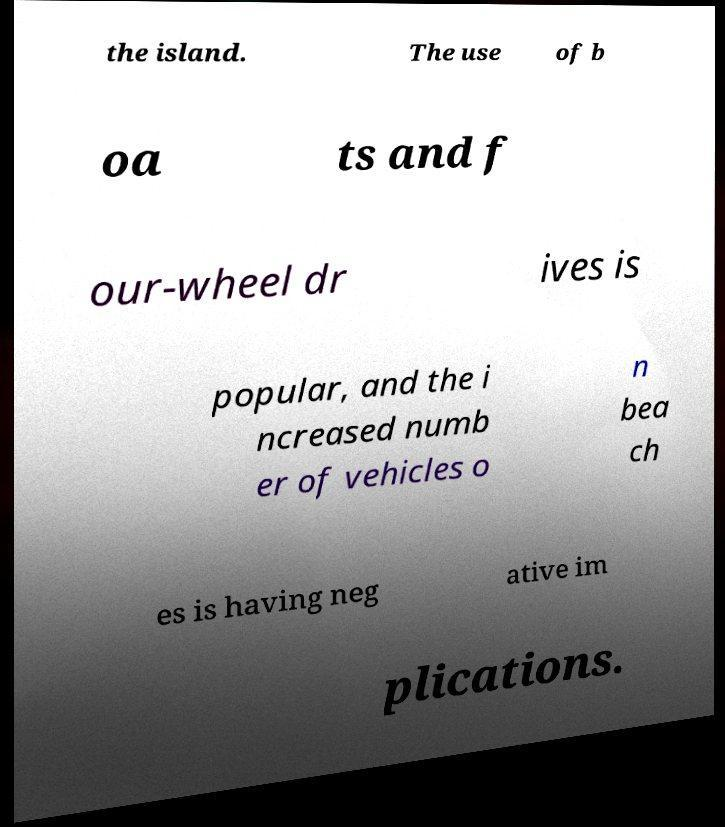I need the written content from this picture converted into text. Can you do that? the island. The use of b oa ts and f our-wheel dr ives is popular, and the i ncreased numb er of vehicles o n bea ch es is having neg ative im plications. 